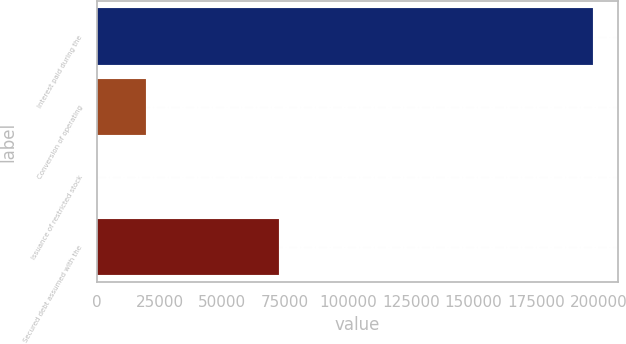Convert chart to OTSL. <chart><loc_0><loc_0><loc_500><loc_500><bar_chart><fcel>Interest paid during the<fcel>Conversion of operating<fcel>Issuance of restricted stock<fcel>Secured debt assumed with the<nl><fcel>197722<fcel>19773.1<fcel>1<fcel>72680<nl></chart> 